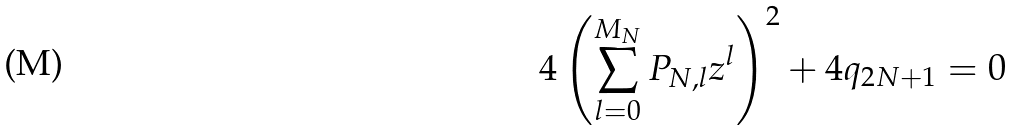<formula> <loc_0><loc_0><loc_500><loc_500>4 \left ( \sum _ { l = 0 } ^ { M _ { N } } P _ { N , l } z ^ { l } \right ) ^ { 2 } + 4 q _ { 2 N + 1 } = 0</formula> 